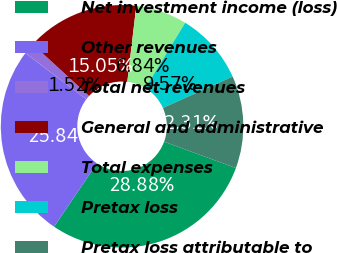Convert chart. <chart><loc_0><loc_0><loc_500><loc_500><pie_chart><fcel>Net investment income (loss)<fcel>Other revenues<fcel>Total net revenues<fcel>General and administrative<fcel>Total expenses<fcel>Pretax loss<fcel>Pretax loss attributable to<nl><fcel>28.88%<fcel>25.84%<fcel>1.52%<fcel>15.05%<fcel>6.84%<fcel>9.57%<fcel>12.31%<nl></chart> 